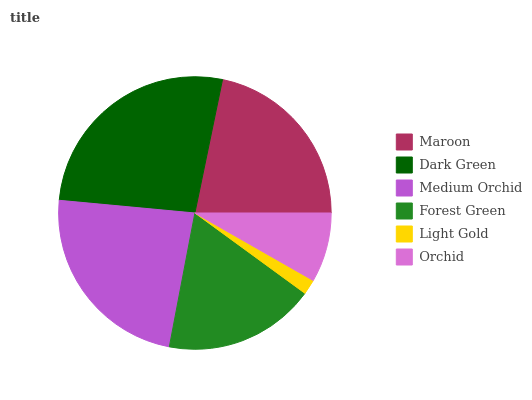Is Light Gold the minimum?
Answer yes or no. Yes. Is Dark Green the maximum?
Answer yes or no. Yes. Is Medium Orchid the minimum?
Answer yes or no. No. Is Medium Orchid the maximum?
Answer yes or no. No. Is Dark Green greater than Medium Orchid?
Answer yes or no. Yes. Is Medium Orchid less than Dark Green?
Answer yes or no. Yes. Is Medium Orchid greater than Dark Green?
Answer yes or no. No. Is Dark Green less than Medium Orchid?
Answer yes or no. No. Is Maroon the high median?
Answer yes or no. Yes. Is Forest Green the low median?
Answer yes or no. Yes. Is Medium Orchid the high median?
Answer yes or no. No. Is Orchid the low median?
Answer yes or no. No. 